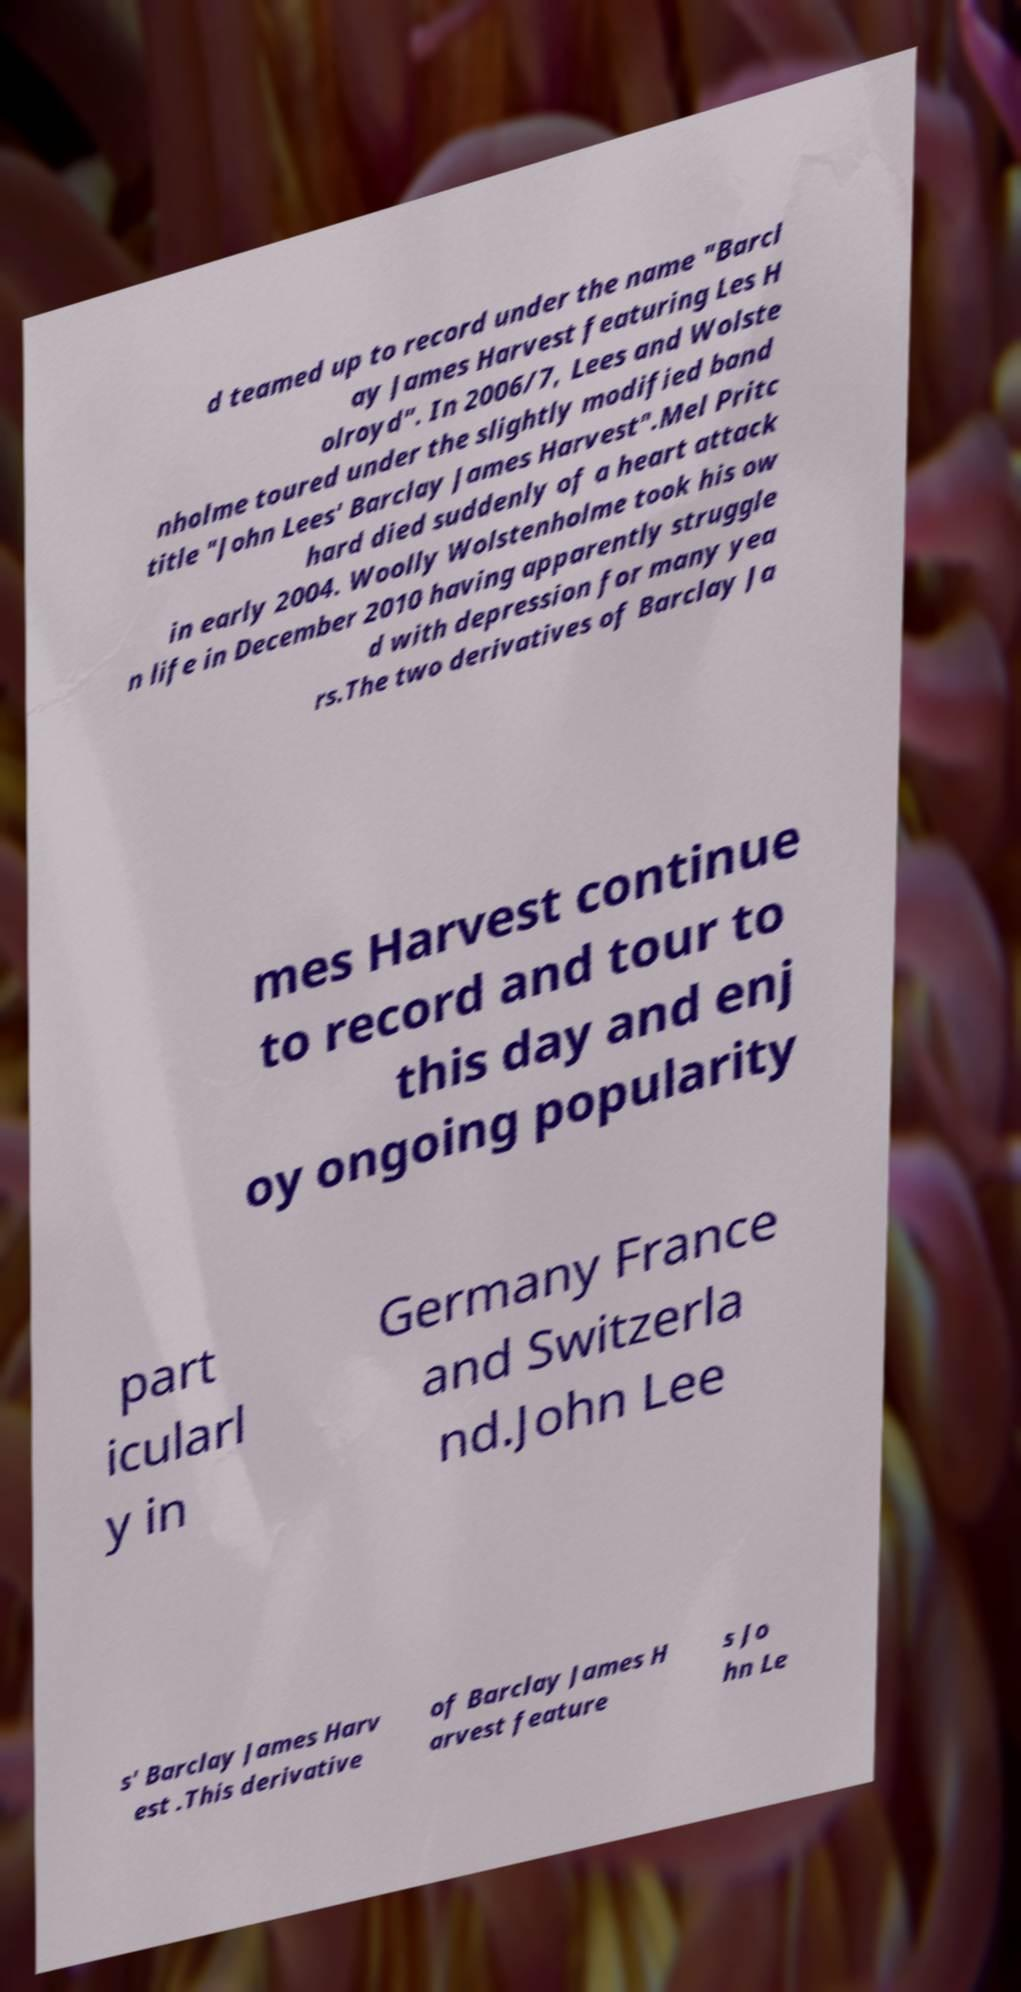Could you extract and type out the text from this image? d teamed up to record under the name "Barcl ay James Harvest featuring Les H olroyd". In 2006/7, Lees and Wolste nholme toured under the slightly modified band title "John Lees' Barclay James Harvest".Mel Pritc hard died suddenly of a heart attack in early 2004. Woolly Wolstenholme took his ow n life in December 2010 having apparently struggle d with depression for many yea rs.The two derivatives of Barclay Ja mes Harvest continue to record and tour to this day and enj oy ongoing popularity part icularl y in Germany France and Switzerla nd.John Lee s' Barclay James Harv est .This derivative of Barclay James H arvest feature s Jo hn Le 